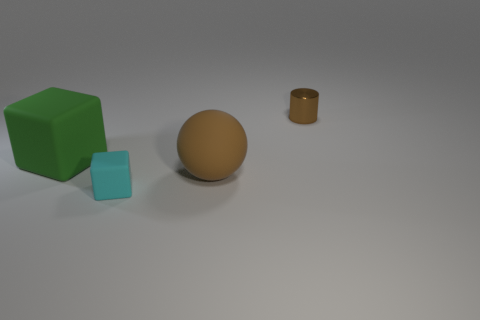Is there a big brown object?
Provide a short and direct response. Yes. What is the material of the object that is the same color as the large matte sphere?
Your answer should be very brief. Metal. What size is the block that is right of the big object that is behind the brown object that is left of the brown cylinder?
Offer a very short reply. Small. There is a small cyan object; is its shape the same as the object that is left of the tiny cyan matte object?
Offer a terse response. Yes. Are there any big matte balls that have the same color as the small shiny cylinder?
Offer a very short reply. Yes. How many cubes are either big blue metallic objects or big green things?
Provide a succinct answer. 1. Is there a big green matte thing of the same shape as the cyan thing?
Ensure brevity in your answer.  Yes. What number of other objects are the same color as the tiny cylinder?
Provide a succinct answer. 1. Are there fewer cubes that are on the right side of the large brown matte thing than tiny cyan things?
Offer a terse response. Yes. How many large rubber objects are there?
Your answer should be very brief. 2. 